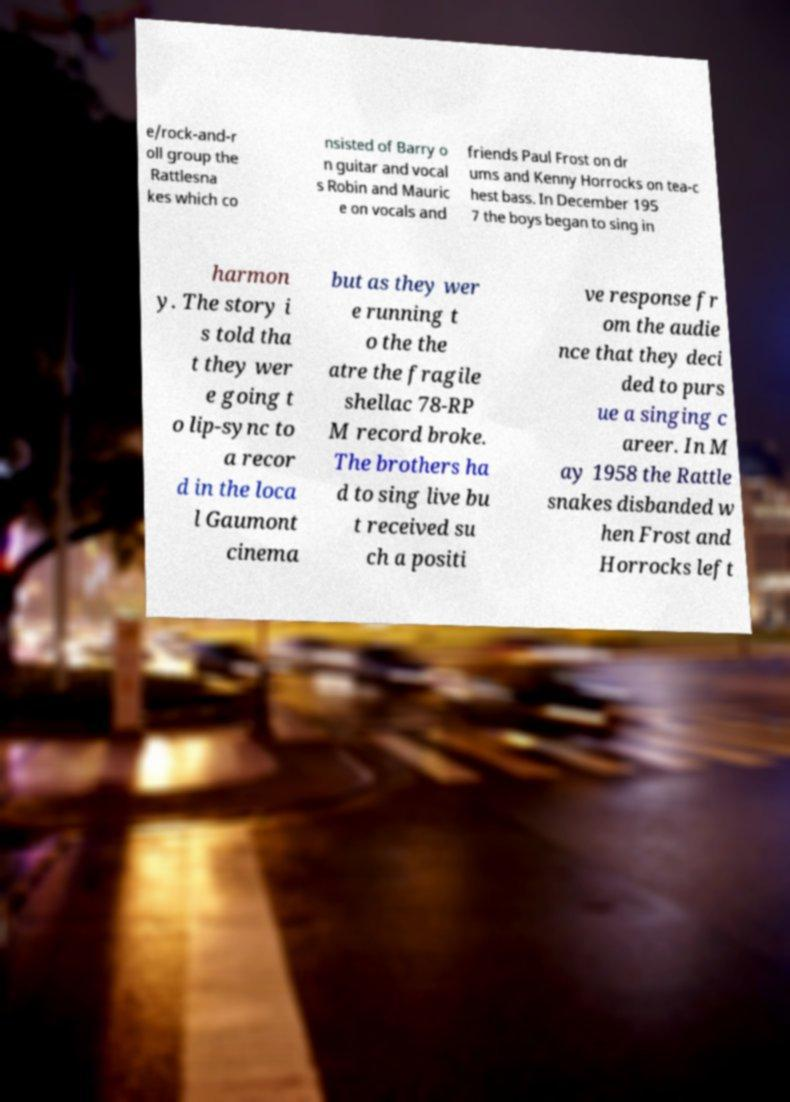For documentation purposes, I need the text within this image transcribed. Could you provide that? e/rock-and-r oll group the Rattlesna kes which co nsisted of Barry o n guitar and vocal s Robin and Mauric e on vocals and friends Paul Frost on dr ums and Kenny Horrocks on tea-c hest bass. In December 195 7 the boys began to sing in harmon y. The story i s told tha t they wer e going t o lip-sync to a recor d in the loca l Gaumont cinema but as they wer e running t o the the atre the fragile shellac 78-RP M record broke. The brothers ha d to sing live bu t received su ch a positi ve response fr om the audie nce that they deci ded to purs ue a singing c areer. In M ay 1958 the Rattle snakes disbanded w hen Frost and Horrocks left 